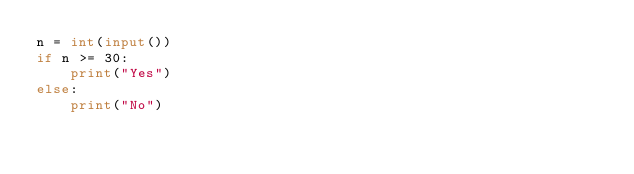Convert code to text. <code><loc_0><loc_0><loc_500><loc_500><_Python_>n = int(input())
if n >= 30:
    print("Yes")
else:
    print("No")
</code> 